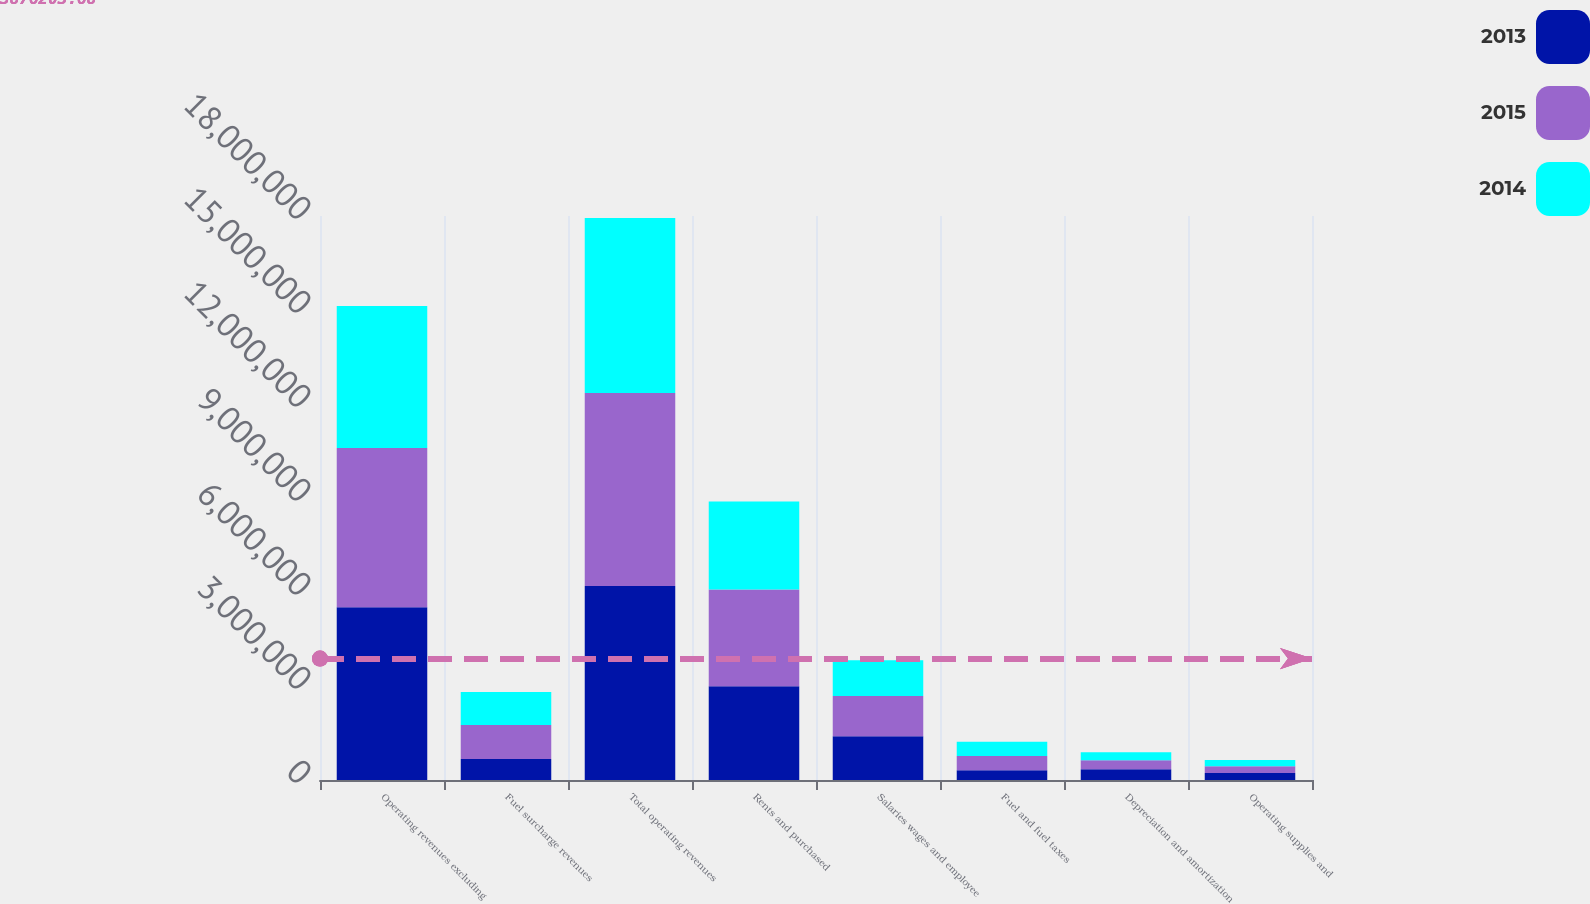<chart> <loc_0><loc_0><loc_500><loc_500><stacked_bar_chart><ecel><fcel>Operating revenues excluding<fcel>Fuel surcharge revenues<fcel>Total operating revenues<fcel>Rents and purchased<fcel>Salaries wages and employee<fcel>Fuel and fuel taxes<fcel>Depreciation and amortization<fcel>Operating supplies and<nl><fcel>2013<fcel>5.51628e+06<fcel>671364<fcel>6.18765e+06<fcel>2.99459e+06<fcel>1.39424e+06<fcel>313034<fcel>339613<fcel>220597<nl><fcel>2015<fcel>5.08283e+06<fcel>1.08261e+06<fcel>6.16544e+06<fcel>3.08528e+06<fcel>1.2904e+06<fcel>453919<fcel>294496<fcel>218539<nl><fcel>2014<fcel>4.52724e+06<fcel>1.05733e+06<fcel>5.58457e+06<fcel>2.80557e+06<fcel>1.13821e+06<fcel>455926<fcel>253380<fcel>202700<nl></chart> 